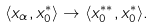Convert formula to latex. <formula><loc_0><loc_0><loc_500><loc_500>\langle x _ { \alpha } , x ^ { * } _ { 0 } \rangle \rightarrow \langle x _ { 0 } ^ { * * } , x ^ { * } _ { 0 } \rangle .</formula> 